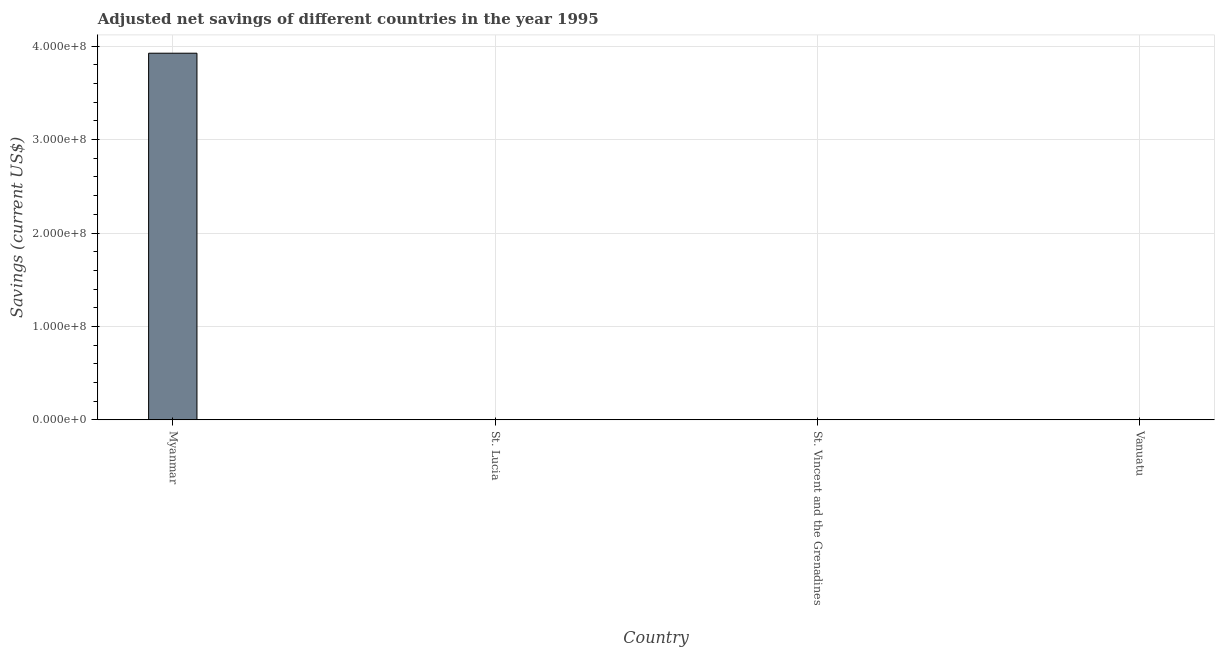Does the graph contain any zero values?
Your answer should be compact. No. What is the title of the graph?
Your response must be concise. Adjusted net savings of different countries in the year 1995. What is the label or title of the X-axis?
Offer a terse response. Country. What is the label or title of the Y-axis?
Offer a very short reply. Savings (current US$). What is the adjusted net savings in St. Lucia?
Provide a succinct answer. 1692.48. Across all countries, what is the maximum adjusted net savings?
Provide a short and direct response. 3.93e+08. Across all countries, what is the minimum adjusted net savings?
Your answer should be very brief. 1692.48. In which country was the adjusted net savings maximum?
Keep it short and to the point. Myanmar. In which country was the adjusted net savings minimum?
Your answer should be compact. St. Lucia. What is the sum of the adjusted net savings?
Offer a very short reply. 3.93e+08. What is the difference between the adjusted net savings in Myanmar and Vanuatu?
Your response must be concise. 3.92e+08. What is the average adjusted net savings per country?
Your answer should be very brief. 9.82e+07. What is the median adjusted net savings?
Give a very brief answer. 2.02e+05. In how many countries, is the adjusted net savings greater than 320000000 US$?
Offer a terse response. 1. What is the ratio of the adjusted net savings in Myanmar to that in St. Lucia?
Your response must be concise. 2.32e+05. Is the difference between the adjusted net savings in St. Vincent and the Grenadines and Vanuatu greater than the difference between any two countries?
Keep it short and to the point. No. What is the difference between the highest and the second highest adjusted net savings?
Provide a succinct answer. 3.92e+08. Is the sum of the adjusted net savings in St. Lucia and St. Vincent and the Grenadines greater than the maximum adjusted net savings across all countries?
Make the answer very short. No. What is the difference between the highest and the lowest adjusted net savings?
Offer a terse response. 3.93e+08. In how many countries, is the adjusted net savings greater than the average adjusted net savings taken over all countries?
Ensure brevity in your answer.  1. Are all the bars in the graph horizontal?
Offer a terse response. No. What is the difference between two consecutive major ticks on the Y-axis?
Offer a very short reply. 1.00e+08. Are the values on the major ticks of Y-axis written in scientific E-notation?
Your response must be concise. Yes. What is the Savings (current US$) in Myanmar?
Provide a succinct answer. 3.93e+08. What is the Savings (current US$) of St. Lucia?
Make the answer very short. 1692.48. What is the Savings (current US$) of St. Vincent and the Grenadines?
Provide a short and direct response. 9.90e+04. What is the Savings (current US$) of Vanuatu?
Provide a succinct answer. 3.05e+05. What is the difference between the Savings (current US$) in Myanmar and St. Lucia?
Keep it short and to the point. 3.93e+08. What is the difference between the Savings (current US$) in Myanmar and St. Vincent and the Grenadines?
Offer a very short reply. 3.92e+08. What is the difference between the Savings (current US$) in Myanmar and Vanuatu?
Offer a terse response. 3.92e+08. What is the difference between the Savings (current US$) in St. Lucia and St. Vincent and the Grenadines?
Offer a very short reply. -9.73e+04. What is the difference between the Savings (current US$) in St. Lucia and Vanuatu?
Make the answer very short. -3.03e+05. What is the difference between the Savings (current US$) in St. Vincent and the Grenadines and Vanuatu?
Ensure brevity in your answer.  -2.06e+05. What is the ratio of the Savings (current US$) in Myanmar to that in St. Lucia?
Provide a short and direct response. 2.32e+05. What is the ratio of the Savings (current US$) in Myanmar to that in St. Vincent and the Grenadines?
Give a very brief answer. 3963.59. What is the ratio of the Savings (current US$) in Myanmar to that in Vanuatu?
Your answer should be very brief. 1287.96. What is the ratio of the Savings (current US$) in St. Lucia to that in St. Vincent and the Grenadines?
Your answer should be compact. 0.02. What is the ratio of the Savings (current US$) in St. Lucia to that in Vanuatu?
Provide a short and direct response. 0.01. What is the ratio of the Savings (current US$) in St. Vincent and the Grenadines to that in Vanuatu?
Offer a very short reply. 0.33. 